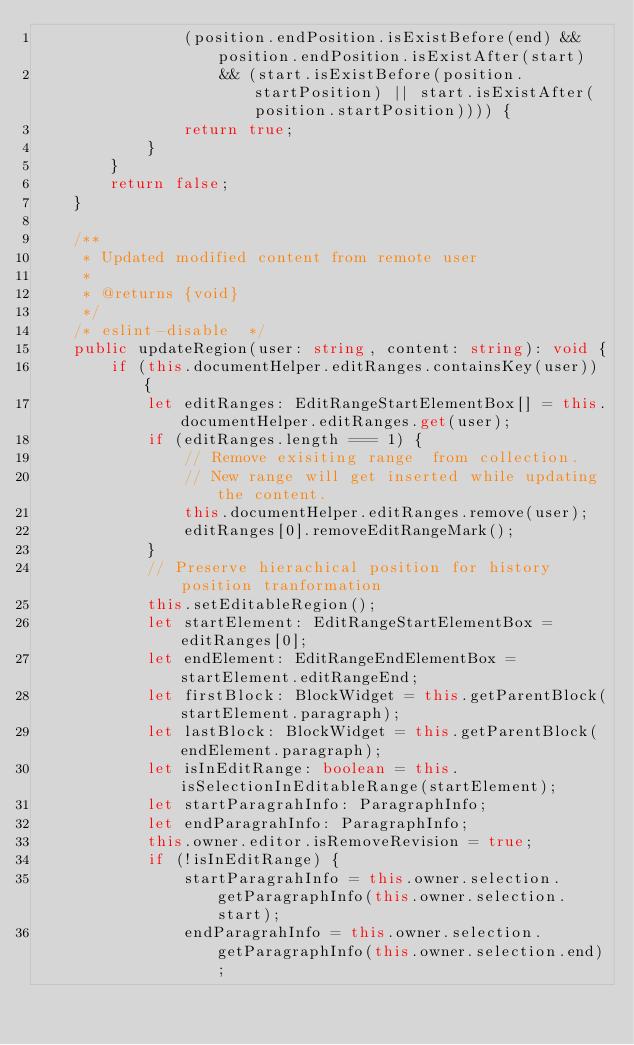<code> <loc_0><loc_0><loc_500><loc_500><_TypeScript_>                (position.endPosition.isExistBefore(end) && position.endPosition.isExistAfter(start)
                    && (start.isExistBefore(position.startPosition) || start.isExistAfter(position.startPosition)))) {
                return true;
            }
        }
        return false;
    }

    /**
     * Updated modified content from remote user
     *
     * @returns {void}
     */
    /* eslint-disable  */
    public updateRegion(user: string, content: string): void {
        if (this.documentHelper.editRanges.containsKey(user)) {
            let editRanges: EditRangeStartElementBox[] = this.documentHelper.editRanges.get(user);
            if (editRanges.length === 1) {
                // Remove exisiting range  from collection.
                // New range will get inserted while updating the content.
                this.documentHelper.editRanges.remove(user);
                editRanges[0].removeEditRangeMark();
            }
            // Preserve hierachical position for history position tranformation
            this.setEditableRegion();
            let startElement: EditRangeStartElementBox = editRanges[0];
            let endElement: EditRangeEndElementBox = startElement.editRangeEnd;
            let firstBlock: BlockWidget = this.getParentBlock(startElement.paragraph);
            let lastBlock: BlockWidget = this.getParentBlock(endElement.paragraph);
            let isInEditRange: boolean = this.isSelectionInEditableRange(startElement);
            let startParagrahInfo: ParagraphInfo;
            let endParagrahInfo: ParagraphInfo;
            this.owner.editor.isRemoveRevision = true;
            if (!isInEditRange) {
                startParagrahInfo = this.owner.selection.getParagraphInfo(this.owner.selection.start);
                endParagrahInfo = this.owner.selection.getParagraphInfo(this.owner.selection.end);</code> 